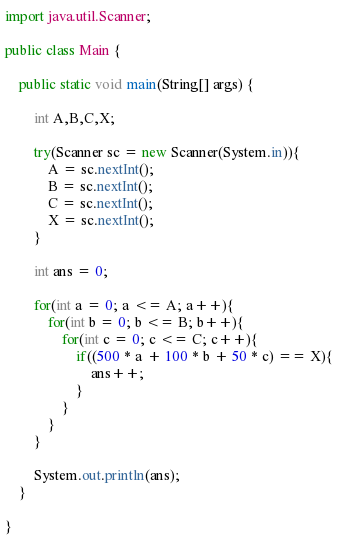<code> <loc_0><loc_0><loc_500><loc_500><_Java_>import java.util.Scanner;

public class Main {

	public static void main(String[] args) {

		int A,B,C,X;

		try(Scanner sc = new Scanner(System.in)){
			A = sc.nextInt();
			B = sc.nextInt();
			C = sc.nextInt();
			X = sc.nextInt();
		}

		int ans = 0;

		for(int a = 0; a <= A; a++){
			for(int b = 0; b <= B; b++){
				for(int c = 0; c <= C; c++){
					if((500 * a + 100 * b + 50 * c) == X){
						ans++;
					}
				}
			}
		}

		System.out.println(ans);
	}

}
</code> 